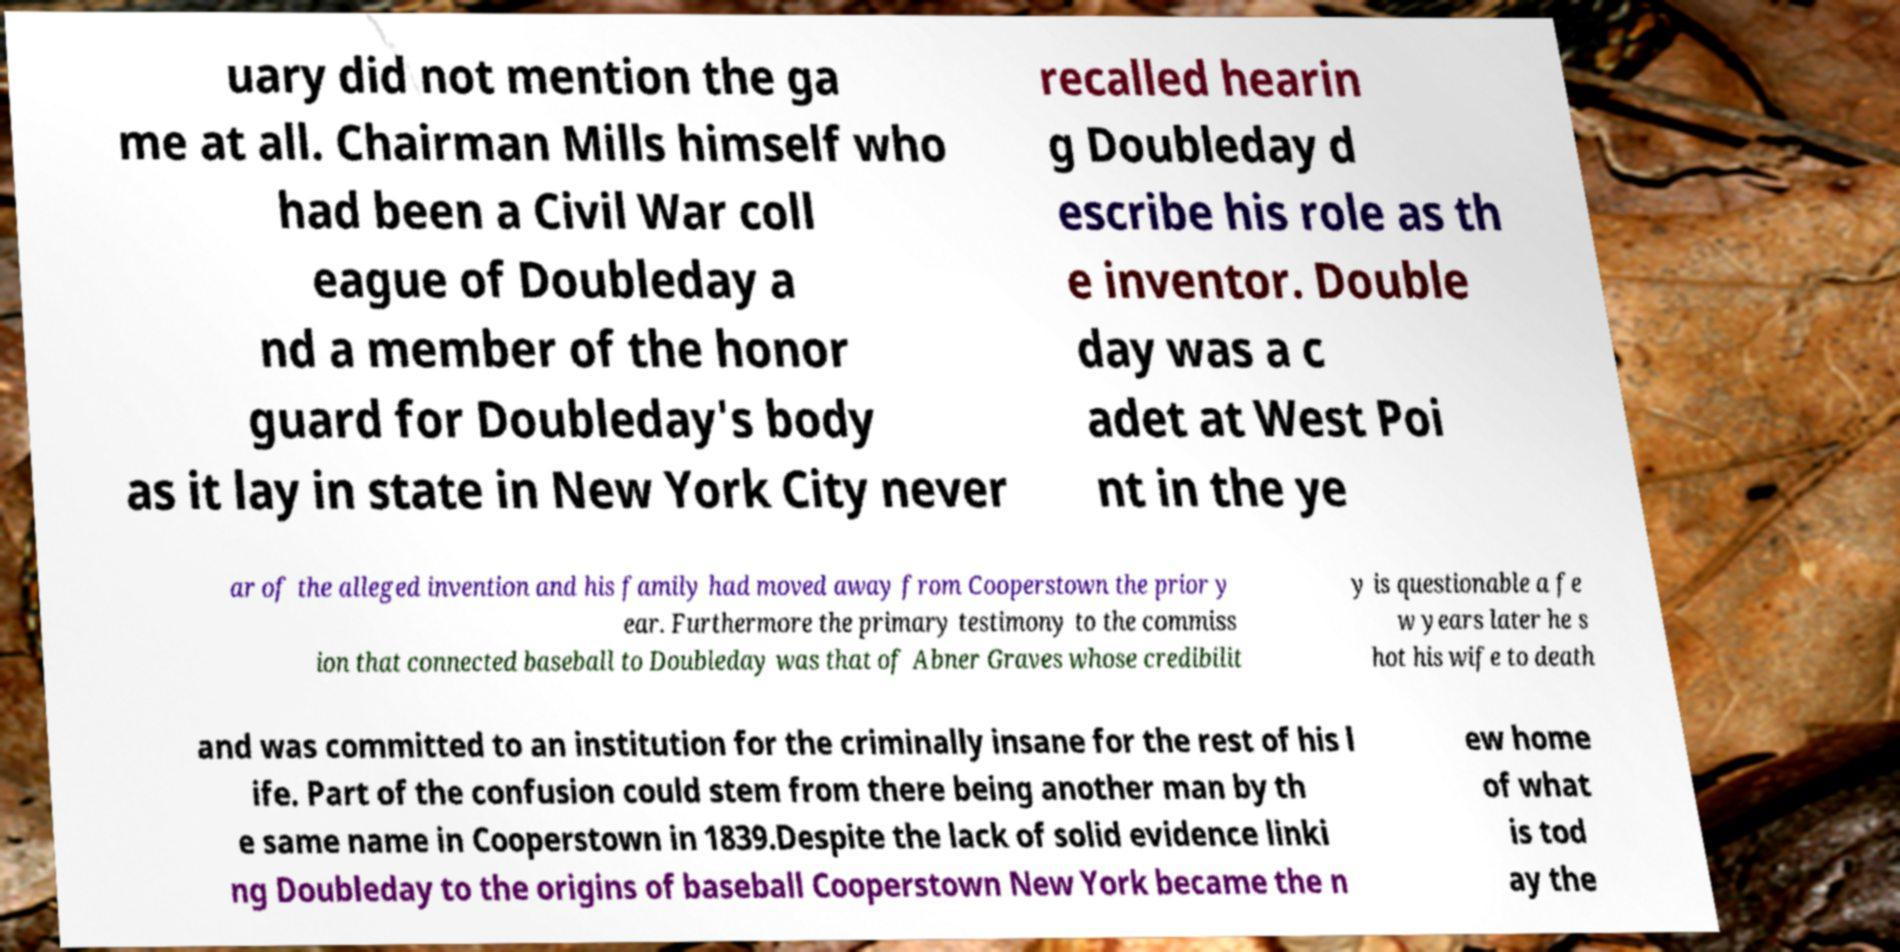What messages or text are displayed in this image? I need them in a readable, typed format. uary did not mention the ga me at all. Chairman Mills himself who had been a Civil War coll eague of Doubleday a nd a member of the honor guard for Doubleday's body as it lay in state in New York City never recalled hearin g Doubleday d escribe his role as th e inventor. Double day was a c adet at West Poi nt in the ye ar of the alleged invention and his family had moved away from Cooperstown the prior y ear. Furthermore the primary testimony to the commiss ion that connected baseball to Doubleday was that of Abner Graves whose credibilit y is questionable a fe w years later he s hot his wife to death and was committed to an institution for the criminally insane for the rest of his l ife. Part of the confusion could stem from there being another man by th e same name in Cooperstown in 1839.Despite the lack of solid evidence linki ng Doubleday to the origins of baseball Cooperstown New York became the n ew home of what is tod ay the 